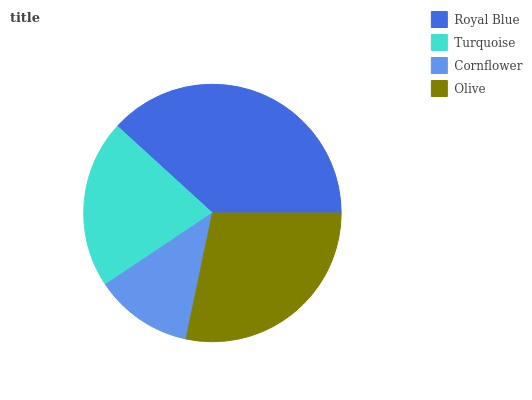Is Cornflower the minimum?
Answer yes or no. Yes. Is Royal Blue the maximum?
Answer yes or no. Yes. Is Turquoise the minimum?
Answer yes or no. No. Is Turquoise the maximum?
Answer yes or no. No. Is Royal Blue greater than Turquoise?
Answer yes or no. Yes. Is Turquoise less than Royal Blue?
Answer yes or no. Yes. Is Turquoise greater than Royal Blue?
Answer yes or no. No. Is Royal Blue less than Turquoise?
Answer yes or no. No. Is Olive the high median?
Answer yes or no. Yes. Is Turquoise the low median?
Answer yes or no. Yes. Is Turquoise the high median?
Answer yes or no. No. Is Cornflower the low median?
Answer yes or no. No. 